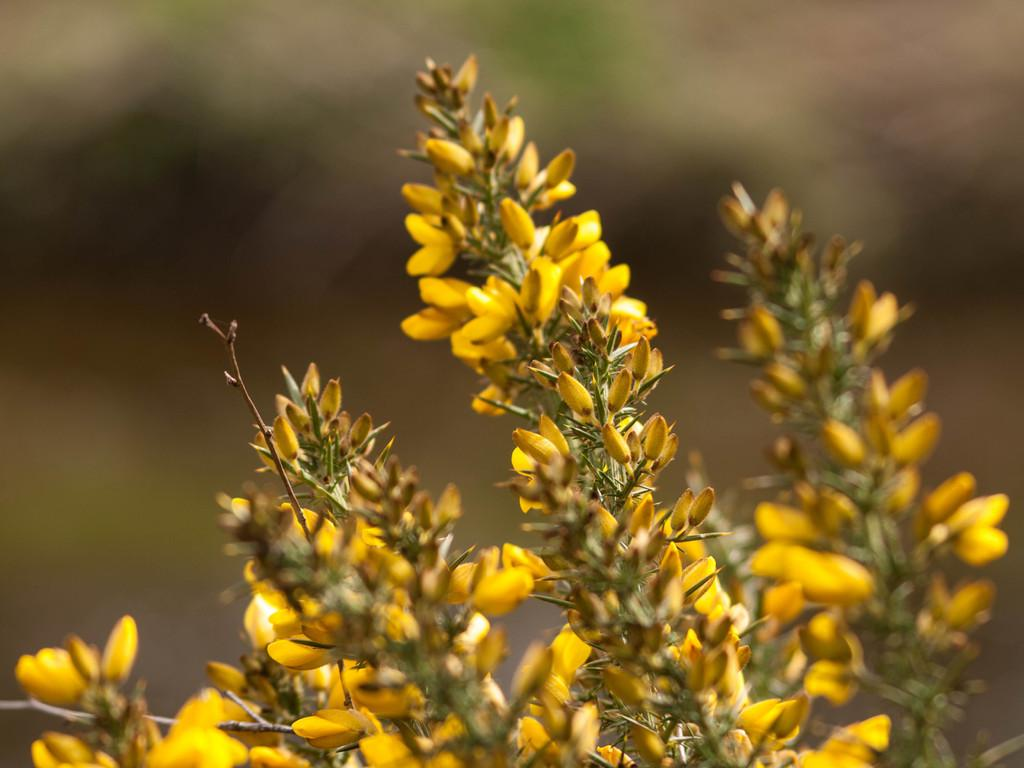What type of flowers can be seen in the image? There are yellow color flowers in the image. Can you describe the stage of growth for some of the flowers? Yes, there are buds in the image. How would you describe the background of the image? The background of the image is blurry. What type of request can be seen in the image? There is no request present in the image; it features yellow color flowers and buds with a blurry background. Can you see any fire or flames in the image? No, there is no fire or flames present in the image. 